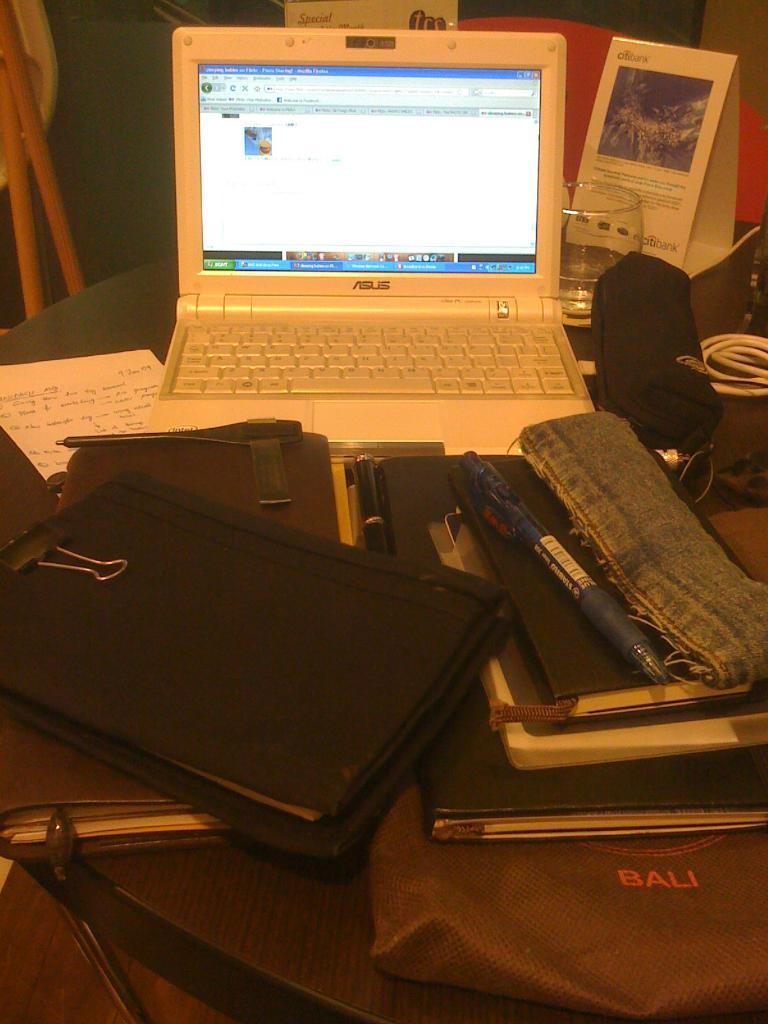<image>
Describe the image concisely. Silver laptop computer open that is made by ASUS 